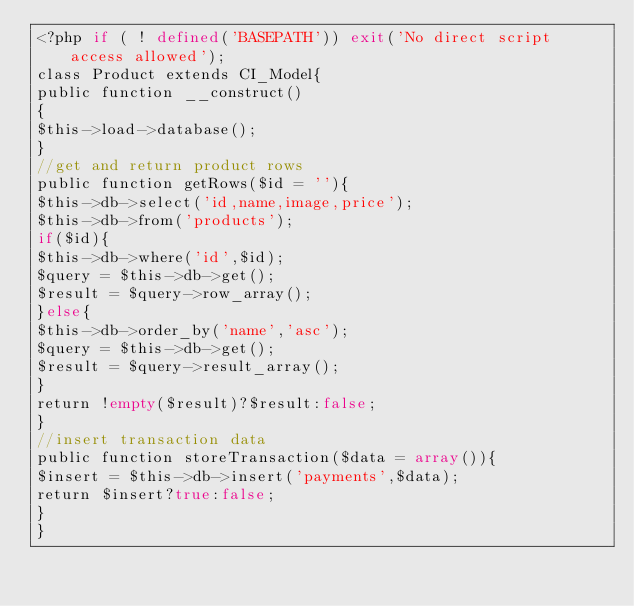Convert code to text. <code><loc_0><loc_0><loc_500><loc_500><_PHP_><?php if ( ! defined('BASEPATH')) exit('No direct script access allowed');
class Product extends CI_Model{
public function __construct()
{
$this->load->database();
}
//get and return product rows
public function getRows($id = ''){
$this->db->select('id,name,image,price');
$this->db->from('products');
if($id){
$this->db->where('id',$id);
$query = $this->db->get();
$result = $query->row_array();
}else{
$this->db->order_by('name','asc');
$query = $this->db->get();
$result = $query->result_array();
}
return !empty($result)?$result:false;
}
//insert transaction data
public function storeTransaction($data = array()){
$insert = $this->db->insert('payments',$data);
return $insert?true:false;
}
}</code> 